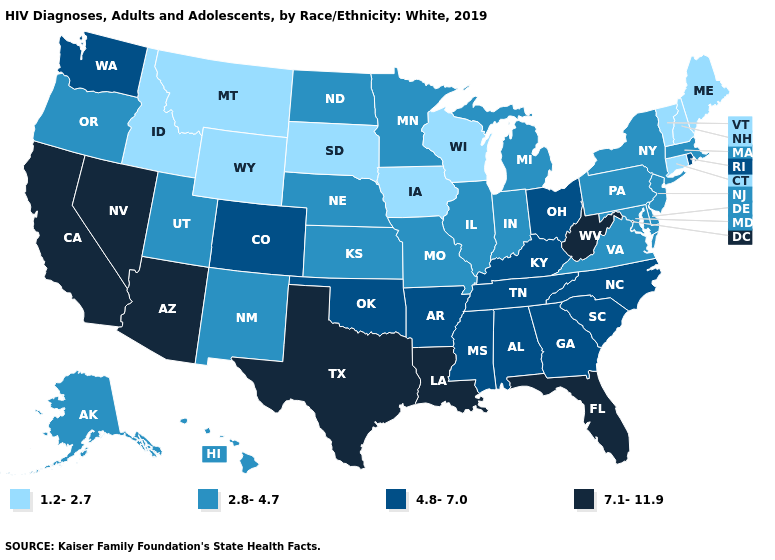Does the map have missing data?
Short answer required. No. What is the value of Texas?
Keep it brief. 7.1-11.9. Among the states that border Arizona , does Nevada have the lowest value?
Write a very short answer. No. Does the map have missing data?
Short answer required. No. Does California have the highest value in the USA?
Short answer required. Yes. Name the states that have a value in the range 2.8-4.7?
Short answer required. Alaska, Delaware, Hawaii, Illinois, Indiana, Kansas, Maryland, Massachusetts, Michigan, Minnesota, Missouri, Nebraska, New Jersey, New Mexico, New York, North Dakota, Oregon, Pennsylvania, Utah, Virginia. What is the value of Connecticut?
Give a very brief answer. 1.2-2.7. What is the lowest value in the South?
Give a very brief answer. 2.8-4.7. Does Oregon have the same value as Utah?
Answer briefly. Yes. Does the map have missing data?
Short answer required. No. What is the lowest value in states that border Montana?
Answer briefly. 1.2-2.7. Which states hav the highest value in the South?
Give a very brief answer. Florida, Louisiana, Texas, West Virginia. Does North Dakota have a higher value than Idaho?
Be succinct. Yes. Which states have the highest value in the USA?
Keep it brief. Arizona, California, Florida, Louisiana, Nevada, Texas, West Virginia. 